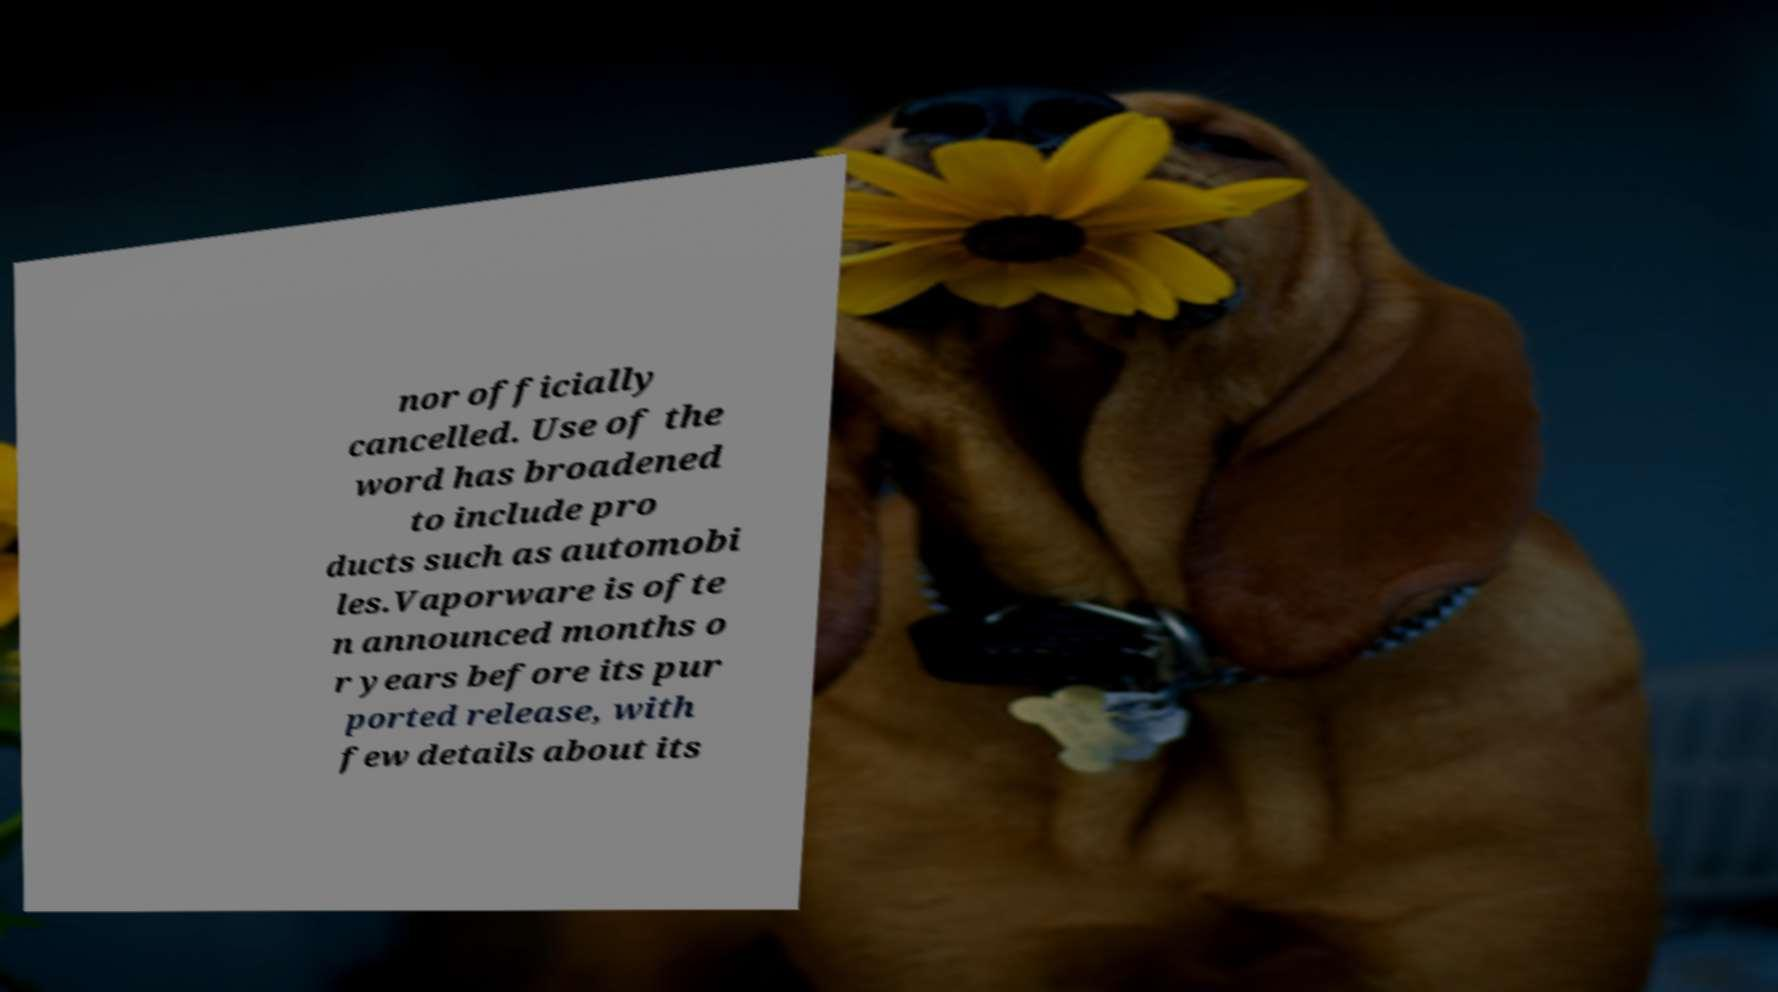There's text embedded in this image that I need extracted. Can you transcribe it verbatim? nor officially cancelled. Use of the word has broadened to include pro ducts such as automobi les.Vaporware is ofte n announced months o r years before its pur ported release, with few details about its 